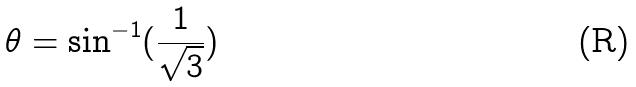Convert formula to latex. <formula><loc_0><loc_0><loc_500><loc_500>\theta = \sin ^ { - 1 } ( \frac { 1 } { \sqrt { 3 } } )</formula> 